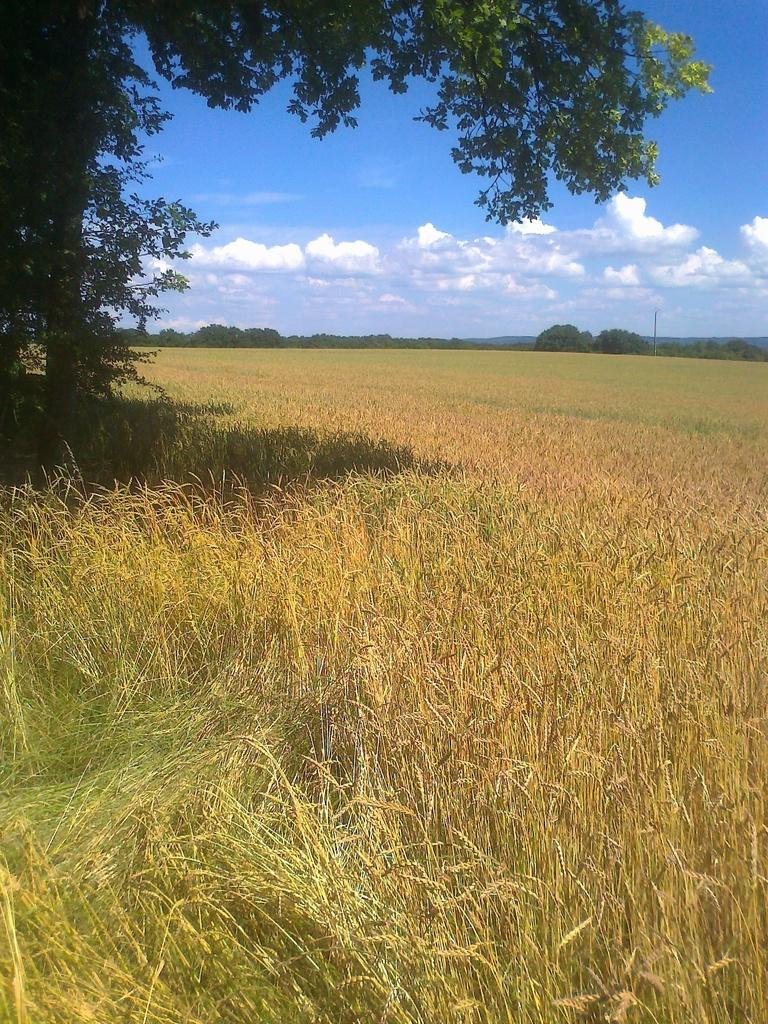What can be seen in the background of the image? In the background of the image, there is a sky with clouds, trees, and a pole. What type of landscape is depicted in the image? The image depicts a field. What color is the minister's tooth in the image? There is no minister or tooth present in the image. 